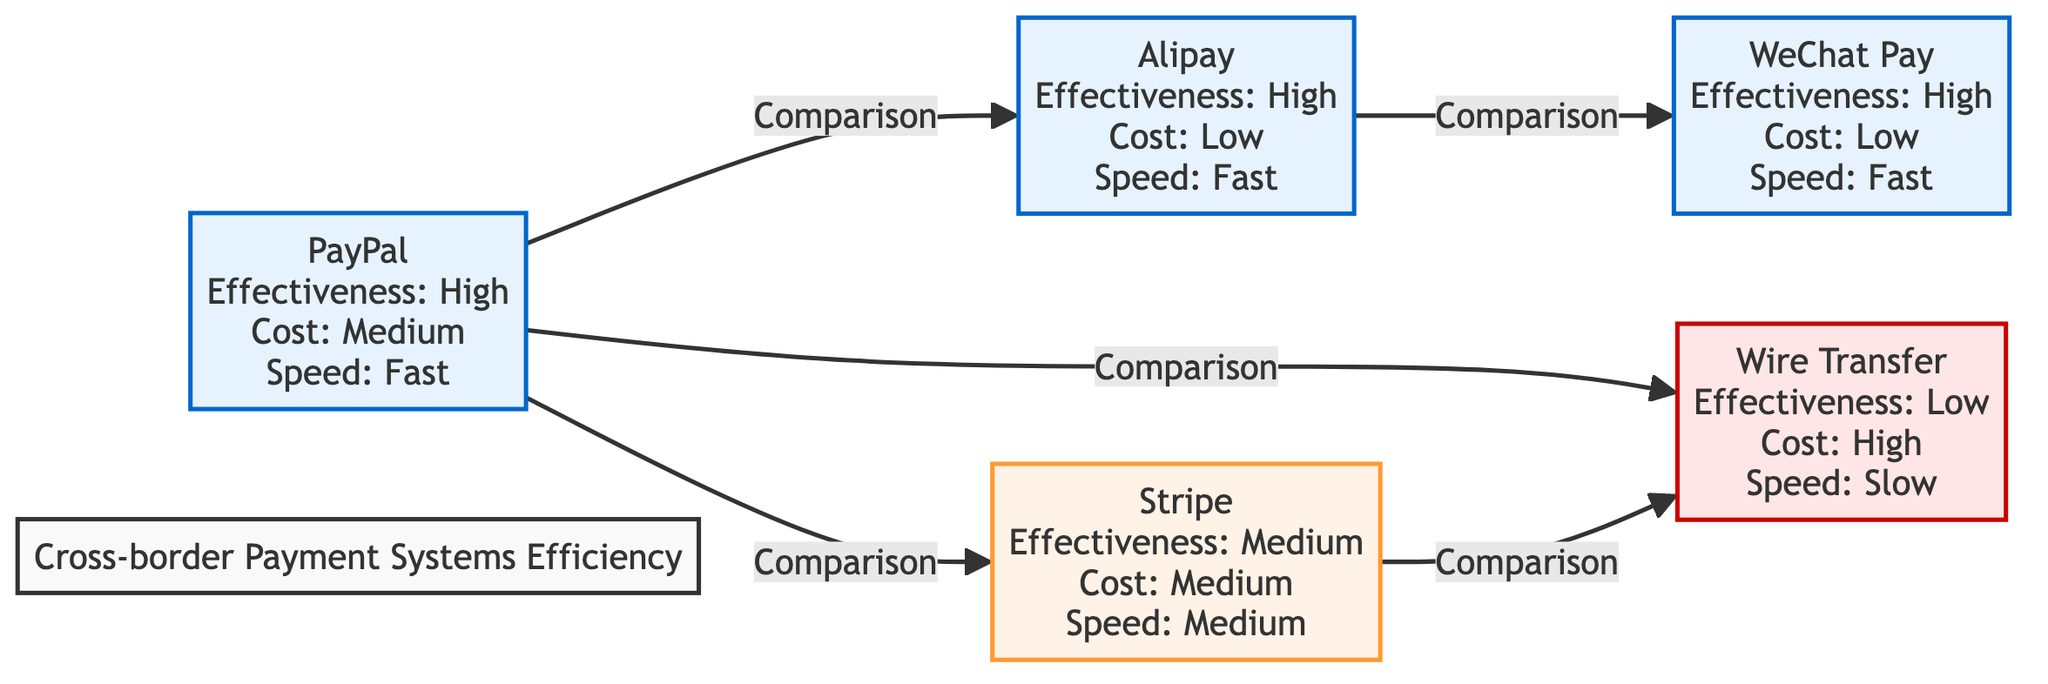What is the effectiveness rating of PayPal? The diagram shows that PayPal has an effectiveness rating of "High." This is directly stated in the node representing PayPal.
Answer: High How many payment methods are listed in the diagram? The diagram contains five payment methods: PayPal, Alipay, Stripe, Wire Transfer, and WeChat Pay. Counting these methods gives a total of five.
Answer: 5 Which payment method has the lowest cost? The diagram indicates that Alipay and WeChat Pay have a cost rating of "Low". Thus, they are the payment methods with the lowest cost.
Answer: Alipay, WeChat Pay What payment method has a 'Slow' speed rating? The node for Wire Transfer is shown as having a 'Slow' speed rating. This is explicitly stated in the node information.
Answer: Wire Transfer How does Alipay compare to WeChat Pay in terms of effectiveness? According to the diagram, both Alipay and WeChat Pay have an effectiveness rating of "High." Therefore, they are equal in this aspect and there is no distinct difference when comparing their effectiveness.
Answer: Equal Which payment method is the only one listed with a 'High' cost rating? The diagram states that Wire Transfer is the only payment method with a 'High' cost rating. This is presented plainly in the node for Wire Transfer.
Answer: Wire Transfer Between Stripe and PayPal, which has a faster transaction speed? The diagram shows that PayPal has a 'Fast' speed rating while Stripe has a 'Medium' speed rating. Therefore, PayPal offers the faster transaction speed compared to Stripe.
Answer: PayPal What two payment methods have a 'Medium' effectiveness rating? The diagram lists Stripe as having a 'Medium' effectiveness rating, and since no others are mentioned with 'Medium,' we find that Stripe is the sole payment method with this rating.
Answer: Stripe Which payment methods are compared with Wire Transfer? The diagram indicates that Wire Transfer is compared with PayPal, Stripe, and Alipay. By reviewing the connections (edges) in the diagram, these three payment methods are noted as being compared to Wire Transfer.
Answer: PayPal, Stripe, Alipay 